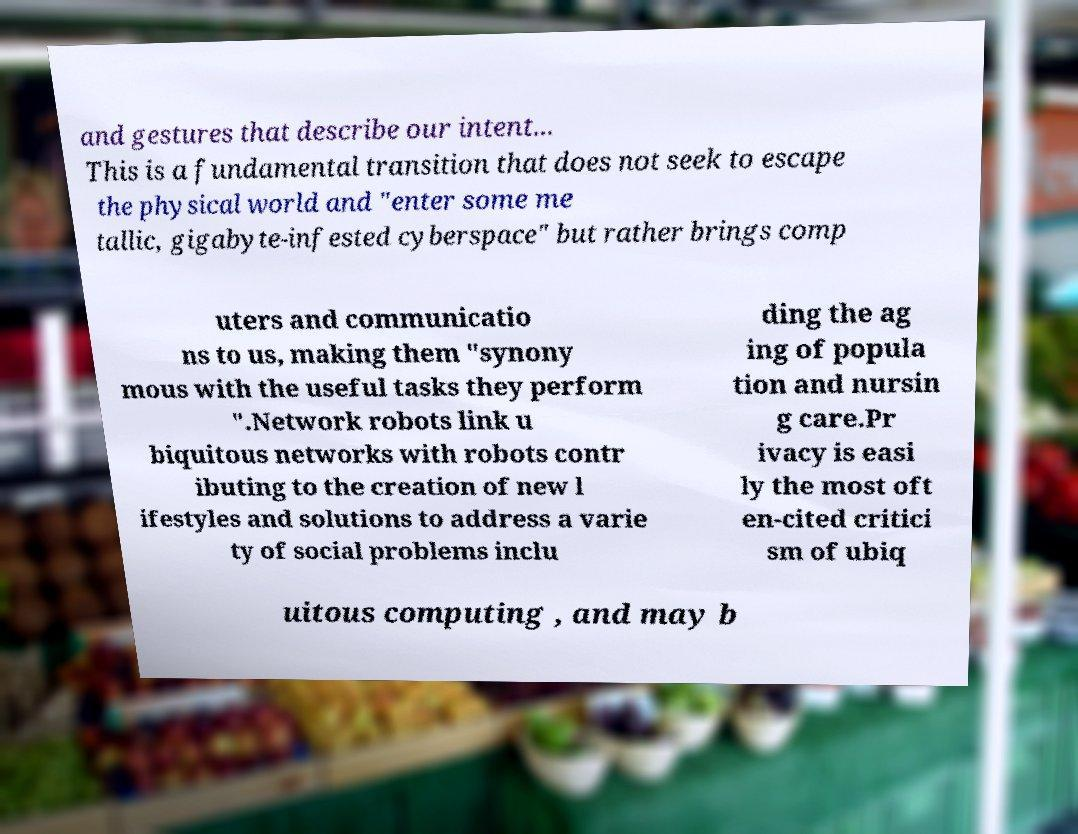Please identify and transcribe the text found in this image. and gestures that describe our intent... This is a fundamental transition that does not seek to escape the physical world and "enter some me tallic, gigabyte-infested cyberspace" but rather brings comp uters and communicatio ns to us, making them "synony mous with the useful tasks they perform ".Network robots link u biquitous networks with robots contr ibuting to the creation of new l ifestyles and solutions to address a varie ty of social problems inclu ding the ag ing of popula tion and nursin g care.Pr ivacy is easi ly the most oft en-cited critici sm of ubiq uitous computing , and may b 